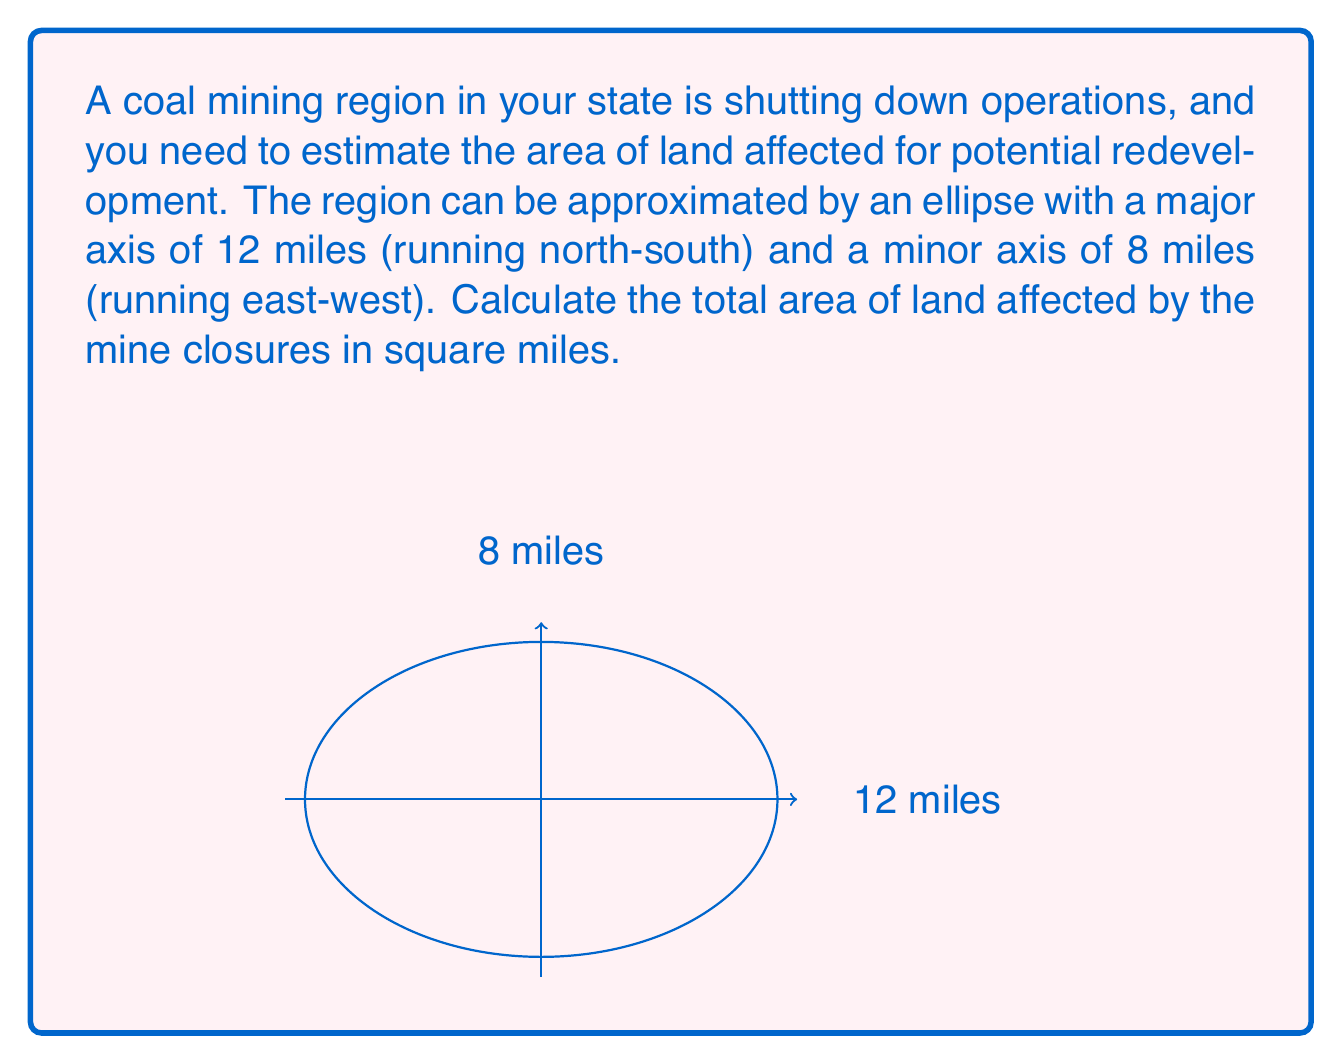Can you solve this math problem? To solve this problem, we'll use the formula for the area of an ellipse:

$$A = \pi ab$$

Where:
$A$ = area of the ellipse
$a$ = length of the semi-major axis (half of the major axis)
$b$ = length of the semi-minor axis (half of the minor axis)

Given:
- Major axis = 12 miles
- Minor axis = 8 miles

Step 1: Calculate the semi-major and semi-minor axes
$a = 12 \div 2 = 6$ miles
$b = 8 \div 2 = 4$ miles

Step 2: Apply the formula for the area of an ellipse
$$A = \pi ab$$
$$A = \pi (6)(4)$$
$$A = 24\pi$$

Step 3: Calculate the final result
$$A = 24\pi \approx 75.40 \text{ square miles}$$

Therefore, the total area of land affected by the mine closures is approximately 75.40 square miles.
Answer: $75.40 \text{ square miles}$ 